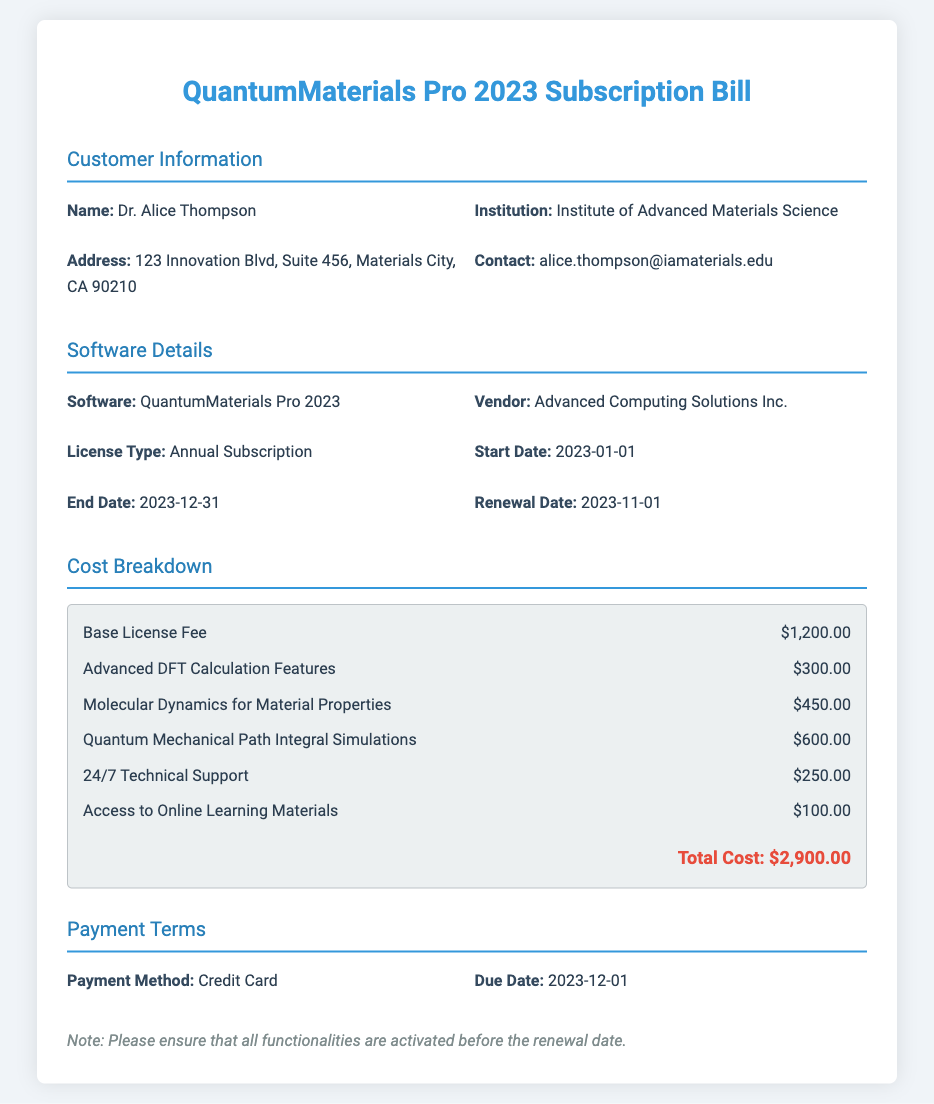What is the total cost of the subscription? The total cost is listed at the end of the cost breakdown section, which adds all the components of the subscription.
Answer: $2,900.00 Who is the customer? The customer's name is provided in the customer information section.
Answer: Dr. Alice Thompson What is the renewal date? The renewal date is specified in the software details section.
Answer: 2023-11-01 What is the start date of the subscription? The start date is provided in the software details section.
Answer: 2023-01-01 How much is the Base License Fee? The cost for the Base License Fee is mentioned in the cost breakdown.
Answer: $1,200.00 What functionality costs the most? The cost breakdown lists the functionalities with their respective prices, the highest one is identified.
Answer: Quantum Mechanical Path Integral Simulations What payment method is used? The document states the payment method in the payment terms section.
Answer: Credit Card What is the due date for payment? The due date is specified in the payment terms section.
Answer: 2023-12-01 Which vendor provides the software? The document reveals the vendor's name in the software details section.
Answer: Advanced Computing Solutions Inc 